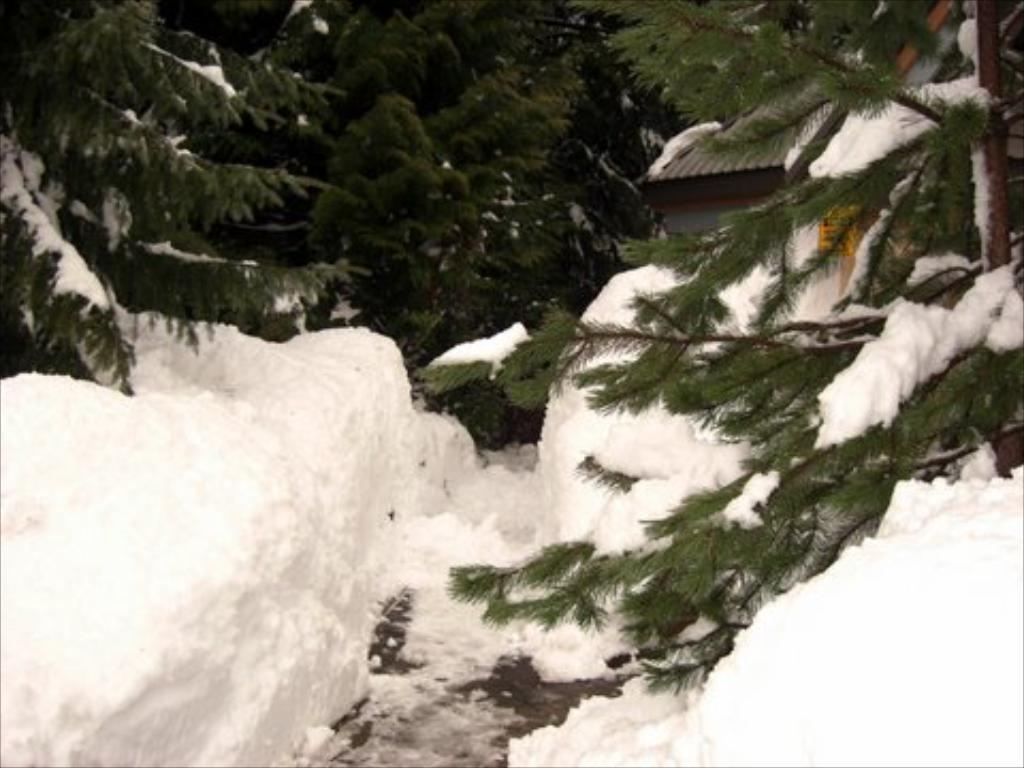What type of vegetation is present in the image? There is a group of trees in the image. How are the trees in the image affected by the weather? The trees are covered with snow. What structure is located on the right side of the image? There is a building on the right side of the image. What features can be seen on the building? The building has windows and a roof. How does the ornament on the tree help the bird in the image? There is no ornament or bird present in the image; it features a group of trees covered in snow and a building with windows and a roof. 